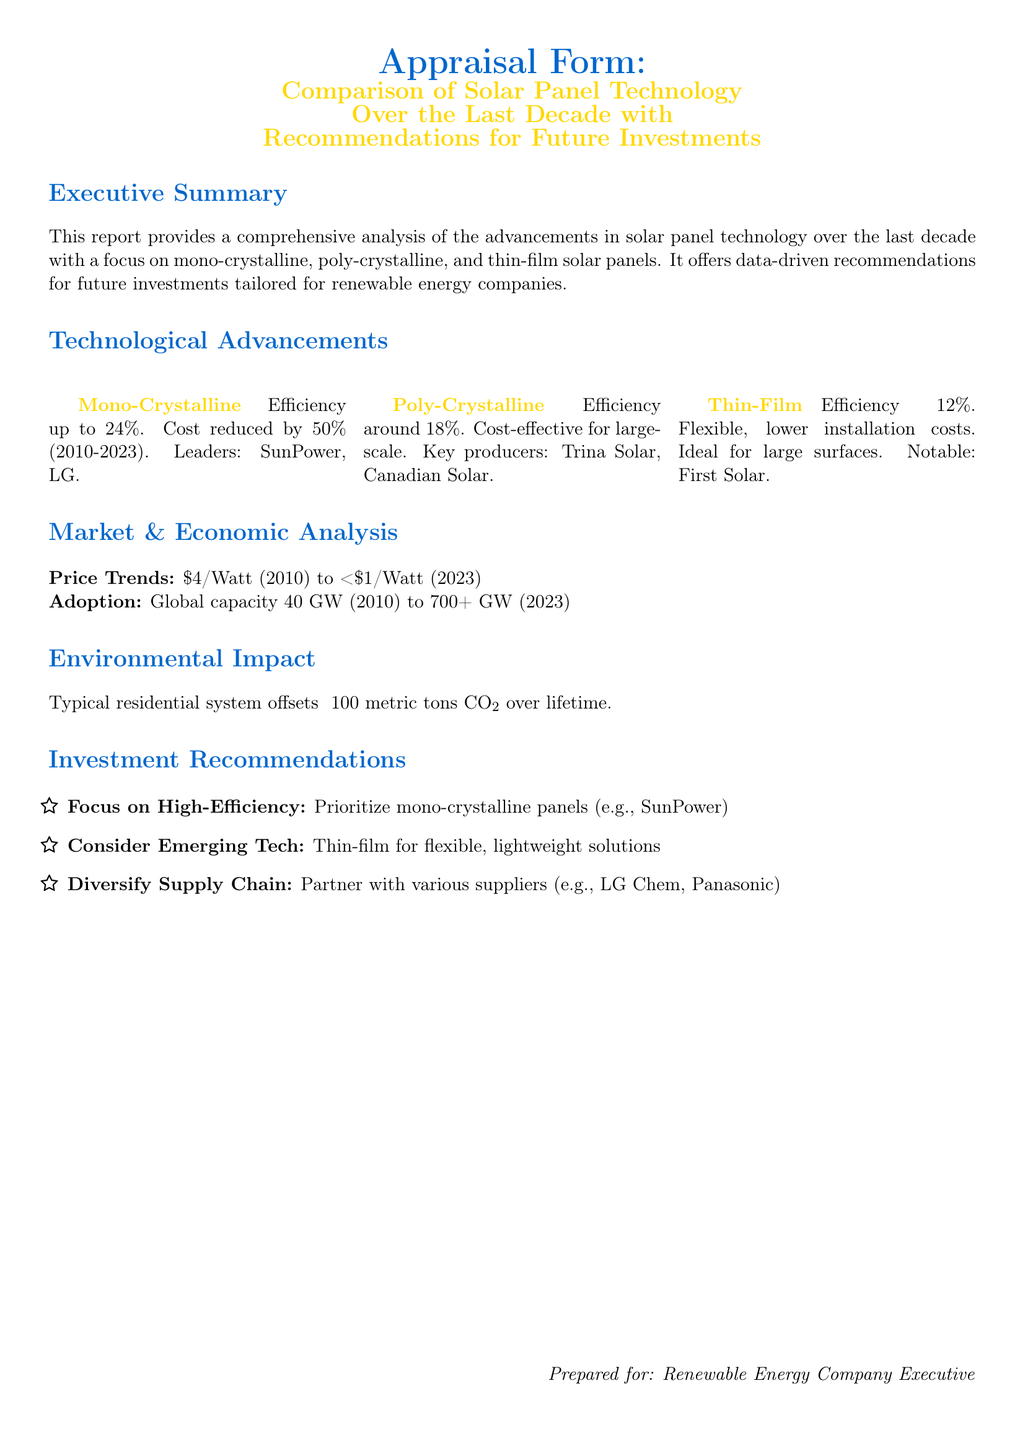what is the efficiency of mono-crystalline panels? The efficiency of mono-crystalline panels is mentioned in the document as up to 24%.
Answer: up to 24% what is the cost of solar panels in 2023? The document states that the cost of solar panels in 2023 is less than $1/Watt.
Answer: <$1/Watt which companies are leading in mono-crystalline production? The leaders in mono-crystalline production are listed as SunPower and LG.
Answer: SunPower, LG how much CO2 does a typical residential system offset over its lifetime? The document states that a typical residential system offsets around 100 metric tons of CO2 over its lifetime.
Answer: ~100 metric tons what is the global capacity of solar energy in 2023? The global capacity of solar energy in 2023 is mentioned to be 700+ GW.
Answer: 700+ GW which solar panel technology is recommended for flexible solutions? The document recommends thin-film technology for flexible, lightweight solutions.
Answer: Thin-film what is the efficiency of thin-film panels? The efficiency of thin-film panels is approximately 12%.
Answer: ~12% which investment strategy involves partnering with suppliers? The document recommends diversifying the supply chain as an investment strategy.
Answer: Diversify Supply Chain 